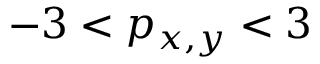Convert formula to latex. <formula><loc_0><loc_0><loc_500><loc_500>- 3 < p _ { x , y } < 3</formula> 